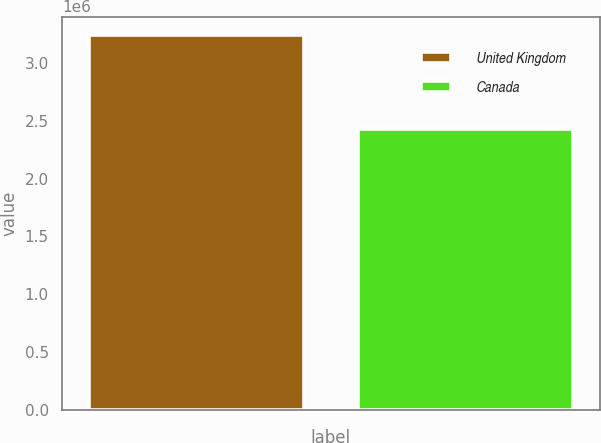<chart> <loc_0><loc_0><loc_500><loc_500><bar_chart><fcel>United Kingdom<fcel>Canada<nl><fcel>3.23904e+06<fcel>2.43096e+06<nl></chart> 